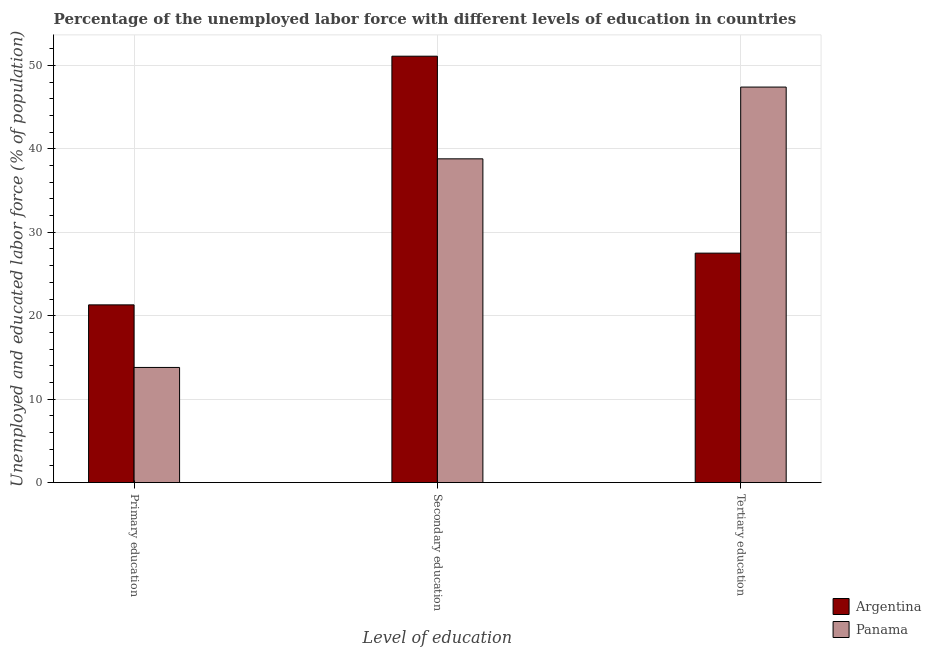How many bars are there on the 3rd tick from the left?
Provide a succinct answer. 2. What is the label of the 3rd group of bars from the left?
Keep it short and to the point. Tertiary education. What is the percentage of labor force who received secondary education in Panama?
Your answer should be compact. 38.8. Across all countries, what is the maximum percentage of labor force who received tertiary education?
Give a very brief answer. 47.4. Across all countries, what is the minimum percentage of labor force who received tertiary education?
Provide a succinct answer. 27.5. In which country was the percentage of labor force who received primary education maximum?
Make the answer very short. Argentina. In which country was the percentage of labor force who received primary education minimum?
Your answer should be very brief. Panama. What is the total percentage of labor force who received primary education in the graph?
Offer a very short reply. 35.1. What is the difference between the percentage of labor force who received primary education in Panama and that in Argentina?
Ensure brevity in your answer.  -7.5. What is the difference between the percentage of labor force who received primary education in Argentina and the percentage of labor force who received secondary education in Panama?
Provide a succinct answer. -17.5. What is the average percentage of labor force who received primary education per country?
Provide a succinct answer. 17.55. What is the difference between the percentage of labor force who received tertiary education and percentage of labor force who received primary education in Argentina?
Your response must be concise. 6.2. In how many countries, is the percentage of labor force who received secondary education greater than 2 %?
Offer a terse response. 2. What is the ratio of the percentage of labor force who received secondary education in Argentina to that in Panama?
Your response must be concise. 1.32. Is the percentage of labor force who received primary education in Panama less than that in Argentina?
Provide a succinct answer. Yes. What is the difference between the highest and the second highest percentage of labor force who received primary education?
Provide a succinct answer. 7.5. What is the difference between the highest and the lowest percentage of labor force who received secondary education?
Provide a succinct answer. 12.3. In how many countries, is the percentage of labor force who received tertiary education greater than the average percentage of labor force who received tertiary education taken over all countries?
Provide a short and direct response. 1. Is the sum of the percentage of labor force who received tertiary education in Panama and Argentina greater than the maximum percentage of labor force who received primary education across all countries?
Ensure brevity in your answer.  Yes. What does the 2nd bar from the left in Primary education represents?
Your answer should be compact. Panama. What does the 1st bar from the right in Secondary education represents?
Offer a very short reply. Panama. Is it the case that in every country, the sum of the percentage of labor force who received primary education and percentage of labor force who received secondary education is greater than the percentage of labor force who received tertiary education?
Provide a succinct answer. Yes. Are all the bars in the graph horizontal?
Keep it short and to the point. No. What is the difference between two consecutive major ticks on the Y-axis?
Your answer should be compact. 10. Are the values on the major ticks of Y-axis written in scientific E-notation?
Make the answer very short. No. Where does the legend appear in the graph?
Your response must be concise. Bottom right. How many legend labels are there?
Give a very brief answer. 2. What is the title of the graph?
Ensure brevity in your answer.  Percentage of the unemployed labor force with different levels of education in countries. Does "Guinea" appear as one of the legend labels in the graph?
Ensure brevity in your answer.  No. What is the label or title of the X-axis?
Offer a very short reply. Level of education. What is the label or title of the Y-axis?
Ensure brevity in your answer.  Unemployed and educated labor force (% of population). What is the Unemployed and educated labor force (% of population) of Argentina in Primary education?
Provide a succinct answer. 21.3. What is the Unemployed and educated labor force (% of population) in Panama in Primary education?
Your answer should be compact. 13.8. What is the Unemployed and educated labor force (% of population) in Argentina in Secondary education?
Your answer should be compact. 51.1. What is the Unemployed and educated labor force (% of population) of Panama in Secondary education?
Provide a short and direct response. 38.8. What is the Unemployed and educated labor force (% of population) of Panama in Tertiary education?
Your answer should be compact. 47.4. Across all Level of education, what is the maximum Unemployed and educated labor force (% of population) of Argentina?
Your answer should be compact. 51.1. Across all Level of education, what is the maximum Unemployed and educated labor force (% of population) in Panama?
Offer a very short reply. 47.4. Across all Level of education, what is the minimum Unemployed and educated labor force (% of population) of Argentina?
Your answer should be compact. 21.3. Across all Level of education, what is the minimum Unemployed and educated labor force (% of population) of Panama?
Offer a very short reply. 13.8. What is the total Unemployed and educated labor force (% of population) in Argentina in the graph?
Provide a succinct answer. 99.9. What is the total Unemployed and educated labor force (% of population) in Panama in the graph?
Offer a very short reply. 100. What is the difference between the Unemployed and educated labor force (% of population) of Argentina in Primary education and that in Secondary education?
Offer a terse response. -29.8. What is the difference between the Unemployed and educated labor force (% of population) of Panama in Primary education and that in Secondary education?
Ensure brevity in your answer.  -25. What is the difference between the Unemployed and educated labor force (% of population) of Panama in Primary education and that in Tertiary education?
Offer a very short reply. -33.6. What is the difference between the Unemployed and educated labor force (% of population) in Argentina in Secondary education and that in Tertiary education?
Your answer should be very brief. 23.6. What is the difference between the Unemployed and educated labor force (% of population) in Panama in Secondary education and that in Tertiary education?
Make the answer very short. -8.6. What is the difference between the Unemployed and educated labor force (% of population) of Argentina in Primary education and the Unemployed and educated labor force (% of population) of Panama in Secondary education?
Your response must be concise. -17.5. What is the difference between the Unemployed and educated labor force (% of population) in Argentina in Primary education and the Unemployed and educated labor force (% of population) in Panama in Tertiary education?
Your answer should be compact. -26.1. What is the difference between the Unemployed and educated labor force (% of population) in Argentina in Secondary education and the Unemployed and educated labor force (% of population) in Panama in Tertiary education?
Offer a terse response. 3.7. What is the average Unemployed and educated labor force (% of population) in Argentina per Level of education?
Make the answer very short. 33.3. What is the average Unemployed and educated labor force (% of population) of Panama per Level of education?
Offer a terse response. 33.33. What is the difference between the Unemployed and educated labor force (% of population) of Argentina and Unemployed and educated labor force (% of population) of Panama in Primary education?
Offer a very short reply. 7.5. What is the difference between the Unemployed and educated labor force (% of population) of Argentina and Unemployed and educated labor force (% of population) of Panama in Tertiary education?
Your response must be concise. -19.9. What is the ratio of the Unemployed and educated labor force (% of population) of Argentina in Primary education to that in Secondary education?
Keep it short and to the point. 0.42. What is the ratio of the Unemployed and educated labor force (% of population) of Panama in Primary education to that in Secondary education?
Provide a short and direct response. 0.36. What is the ratio of the Unemployed and educated labor force (% of population) in Argentina in Primary education to that in Tertiary education?
Ensure brevity in your answer.  0.77. What is the ratio of the Unemployed and educated labor force (% of population) in Panama in Primary education to that in Tertiary education?
Your response must be concise. 0.29. What is the ratio of the Unemployed and educated labor force (% of population) of Argentina in Secondary education to that in Tertiary education?
Provide a short and direct response. 1.86. What is the ratio of the Unemployed and educated labor force (% of population) in Panama in Secondary education to that in Tertiary education?
Provide a short and direct response. 0.82. What is the difference between the highest and the second highest Unemployed and educated labor force (% of population) of Argentina?
Offer a very short reply. 23.6. What is the difference between the highest and the lowest Unemployed and educated labor force (% of population) in Argentina?
Provide a succinct answer. 29.8. What is the difference between the highest and the lowest Unemployed and educated labor force (% of population) in Panama?
Keep it short and to the point. 33.6. 